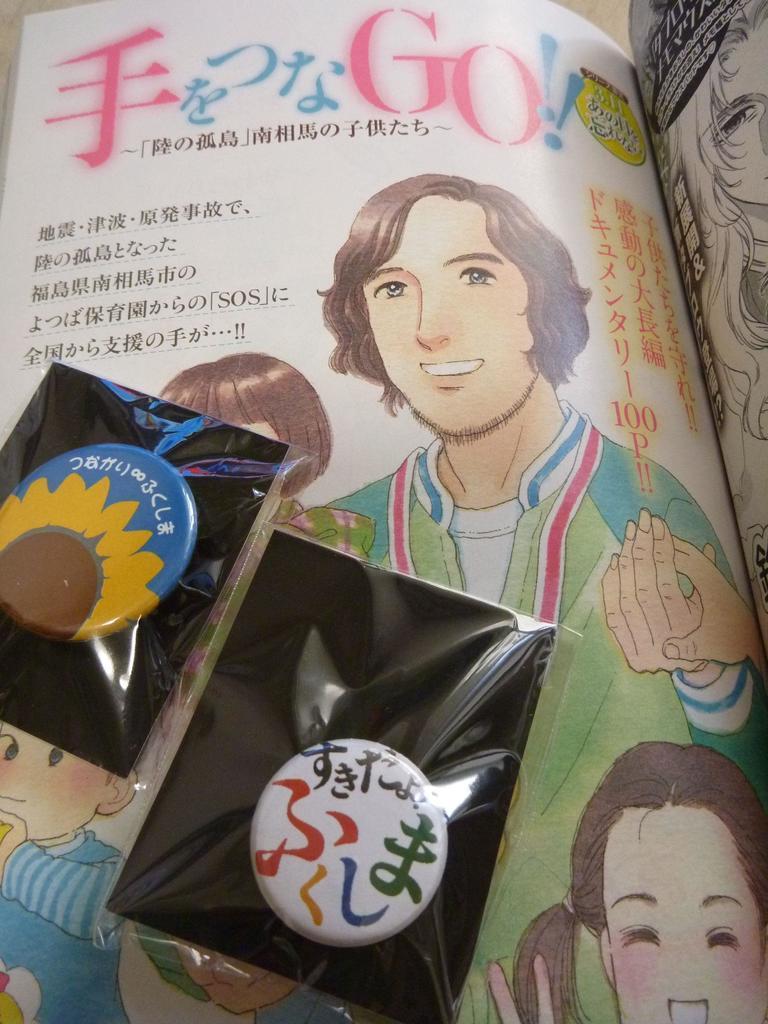Could you give a brief overview of what you see in this image? In this image I can see there is a book. And on the book there are some images and text written on it. In the book there is a badge inside the cover. 